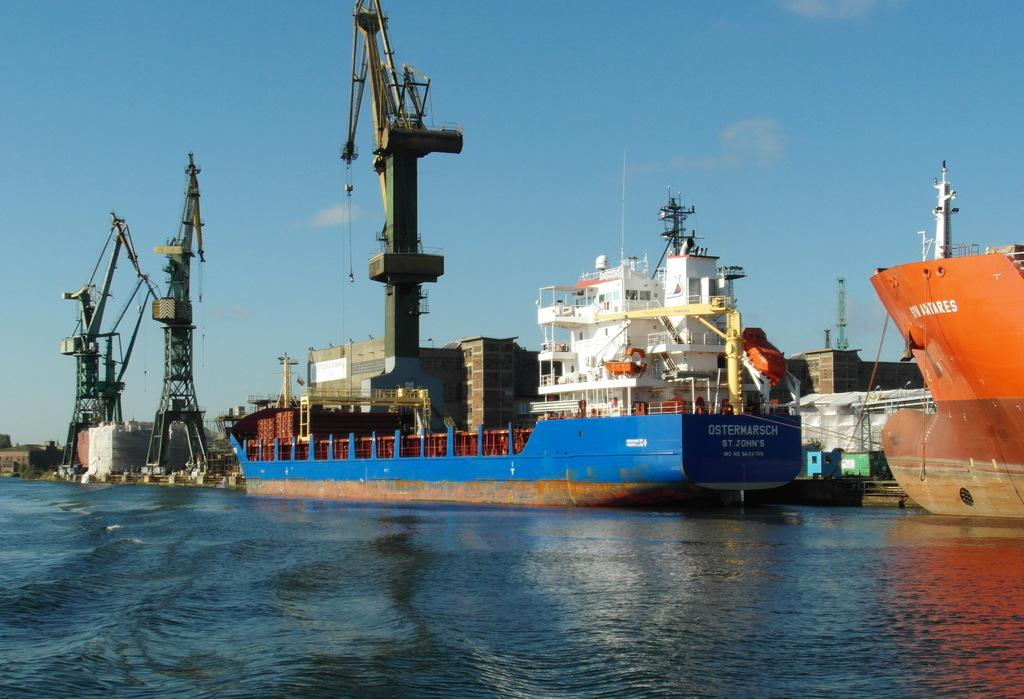What is in the front of the image? There is water in the front of the image. What can be seen in the background of the image? There are ships, towers, and buildings in the background of the image. What is the condition of the sky in the image? The sky is cloudy in the image. Where is the sugar located in the image? There is no sugar present in the image. Who is the writer in the image? There is no writer present in the image. 